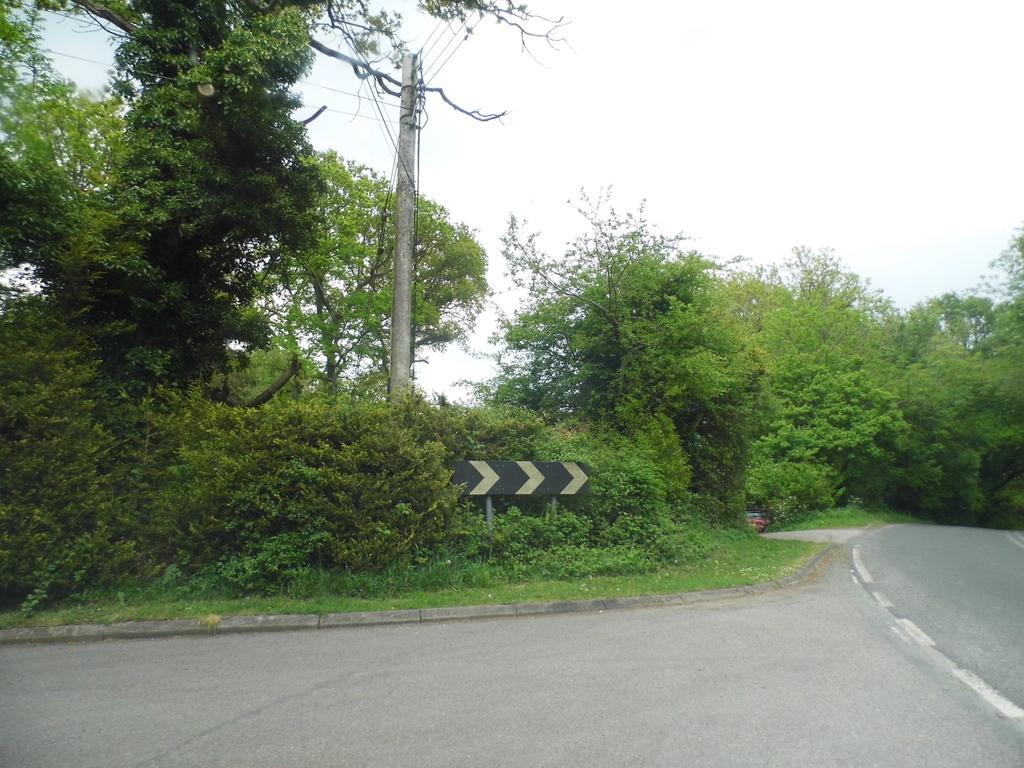Describe this image in one or two sentences. In this image there are trees. At the bottom there is a road we can see grass. In the center there is a pole and we can see a board. In the background there are wires and sky. 